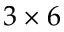Convert formula to latex. <formula><loc_0><loc_0><loc_500><loc_500>3 \times 6</formula> 